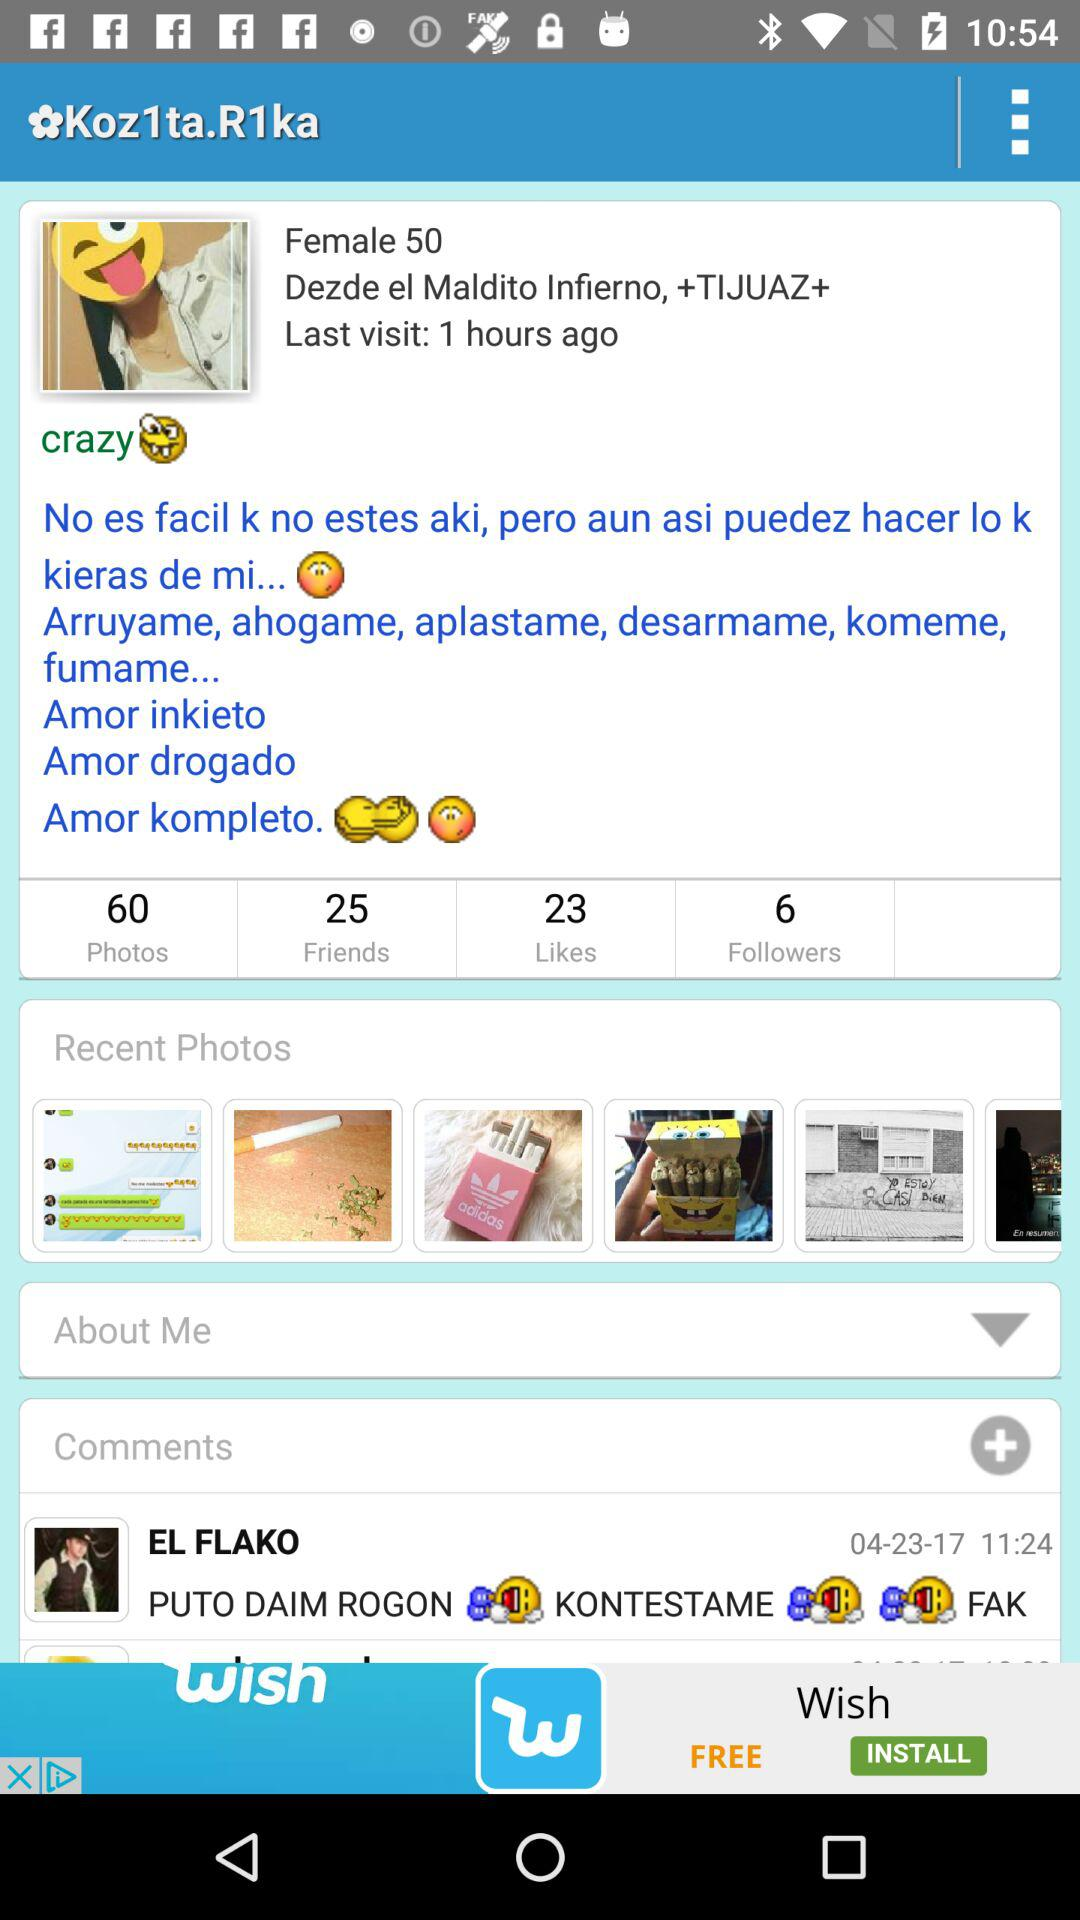What's the number of friends? The number of friends is 25. 